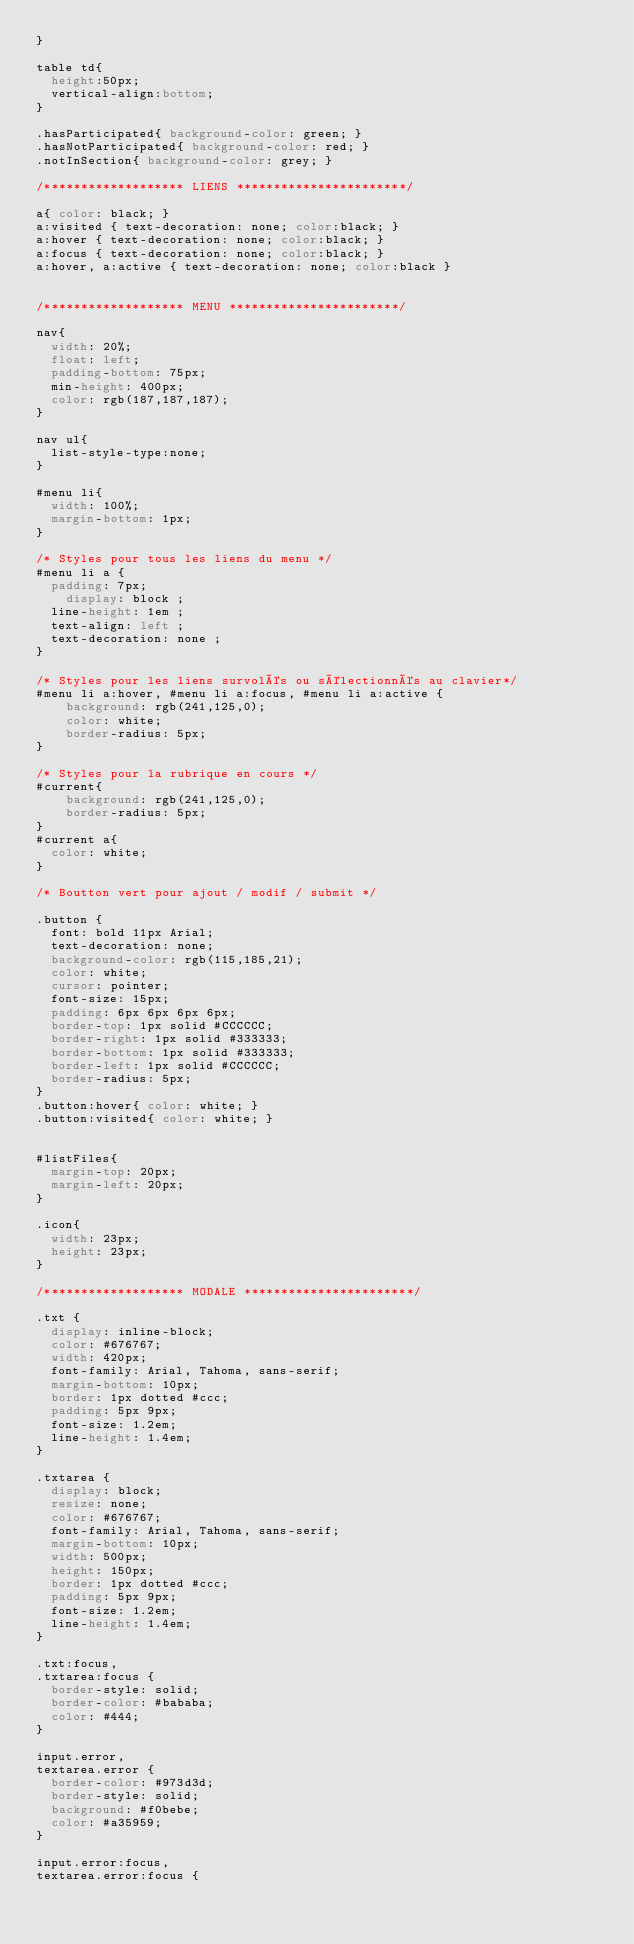Convert code to text. <code><loc_0><loc_0><loc_500><loc_500><_CSS_>}

table td{
	height:50px;
	vertical-align:bottom;
}

.hasParticipated{ background-color: green; }
.hasNotParticipated{ background-color: red; }
.notInSection{ background-color: grey; }

/******************* LIENS ***********************/

a{ color: black; }
a:visited { text-decoration: none; color:black; }
a:hover { text-decoration: none; color:black; }
a:focus { text-decoration: none; color:black; }
a:hover, a:active { text-decoration: none; color:black }


/******************* MENU ***********************/

nav{
	width: 20%;
	float: left;
	padding-bottom: 75px;
	min-height: 400px;
	color: rgb(187,187,187);
}

nav ul{
	list-style-type:none;
}

#menu li{
	width: 100%;
	margin-bottom: 1px;
}

/* Styles pour tous les liens du menu */
#menu li a {
	padding: 7px;
    display: block ;
	line-height: 1em ;
	text-align: left ;
	text-decoration: none ;
}

/* Styles pour les liens survolés ou sélectionnés au clavier*/
#menu li a:hover, #menu li a:focus, #menu li a:active {
  	background: rgb(241,125,0);
  	color: white;
  	border-radius: 5px;
}

/* Styles pour la rubrique en cours */
#current{
    background: rgb(241,125,0);
    border-radius: 5px;
}
#current a{
	color: white;
}

/* Boutton vert pour ajout / modif / submit */

.button {
  font: bold 11px Arial;
  text-decoration: none;
  background-color: rgb(115,185,21);
  color: white;
  cursor: pointer;
  font-size: 15px;
  padding: 6px 6px 6px 6px;
  border-top: 1px solid #CCCCCC;
  border-right: 1px solid #333333;
  border-bottom: 1px solid #333333;
  border-left: 1px solid #CCCCCC;
  border-radius: 5px;
}
.button:hover{ color: white; }
.button:visited{ color: white; }


#listFiles{
	margin-top: 20px;
	margin-left: 20px;
}

.icon{
	width: 23px;
	height: 23px;
}

/******************* MODALE ***********************/

.txt {
	display: inline-block;
	color: #676767;
	width: 420px;
	font-family: Arial, Tahoma, sans-serif;
	margin-bottom: 10px;
	border: 1px dotted #ccc;
	padding: 5px 9px;
	font-size: 1.2em;
	line-height: 1.4em;
}

.txtarea {
	display: block;
	resize: none;
	color: #676767;
	font-family: Arial, Tahoma, sans-serif;
	margin-bottom: 10px;
	width: 500px;
	height: 150px;
	border: 1px dotted #ccc;
	padding: 5px 9px;
	font-size: 1.2em;
	line-height: 1.4em;
}

.txt:focus,
.txtarea:focus {
	border-style: solid;
	border-color: #bababa;
	color: #444;
}

input.error,
textarea.error {
	border-color: #973d3d;
	border-style: solid;
	background: #f0bebe;
	color: #a35959;
}

input.error:focus,
textarea.error:focus {</code> 